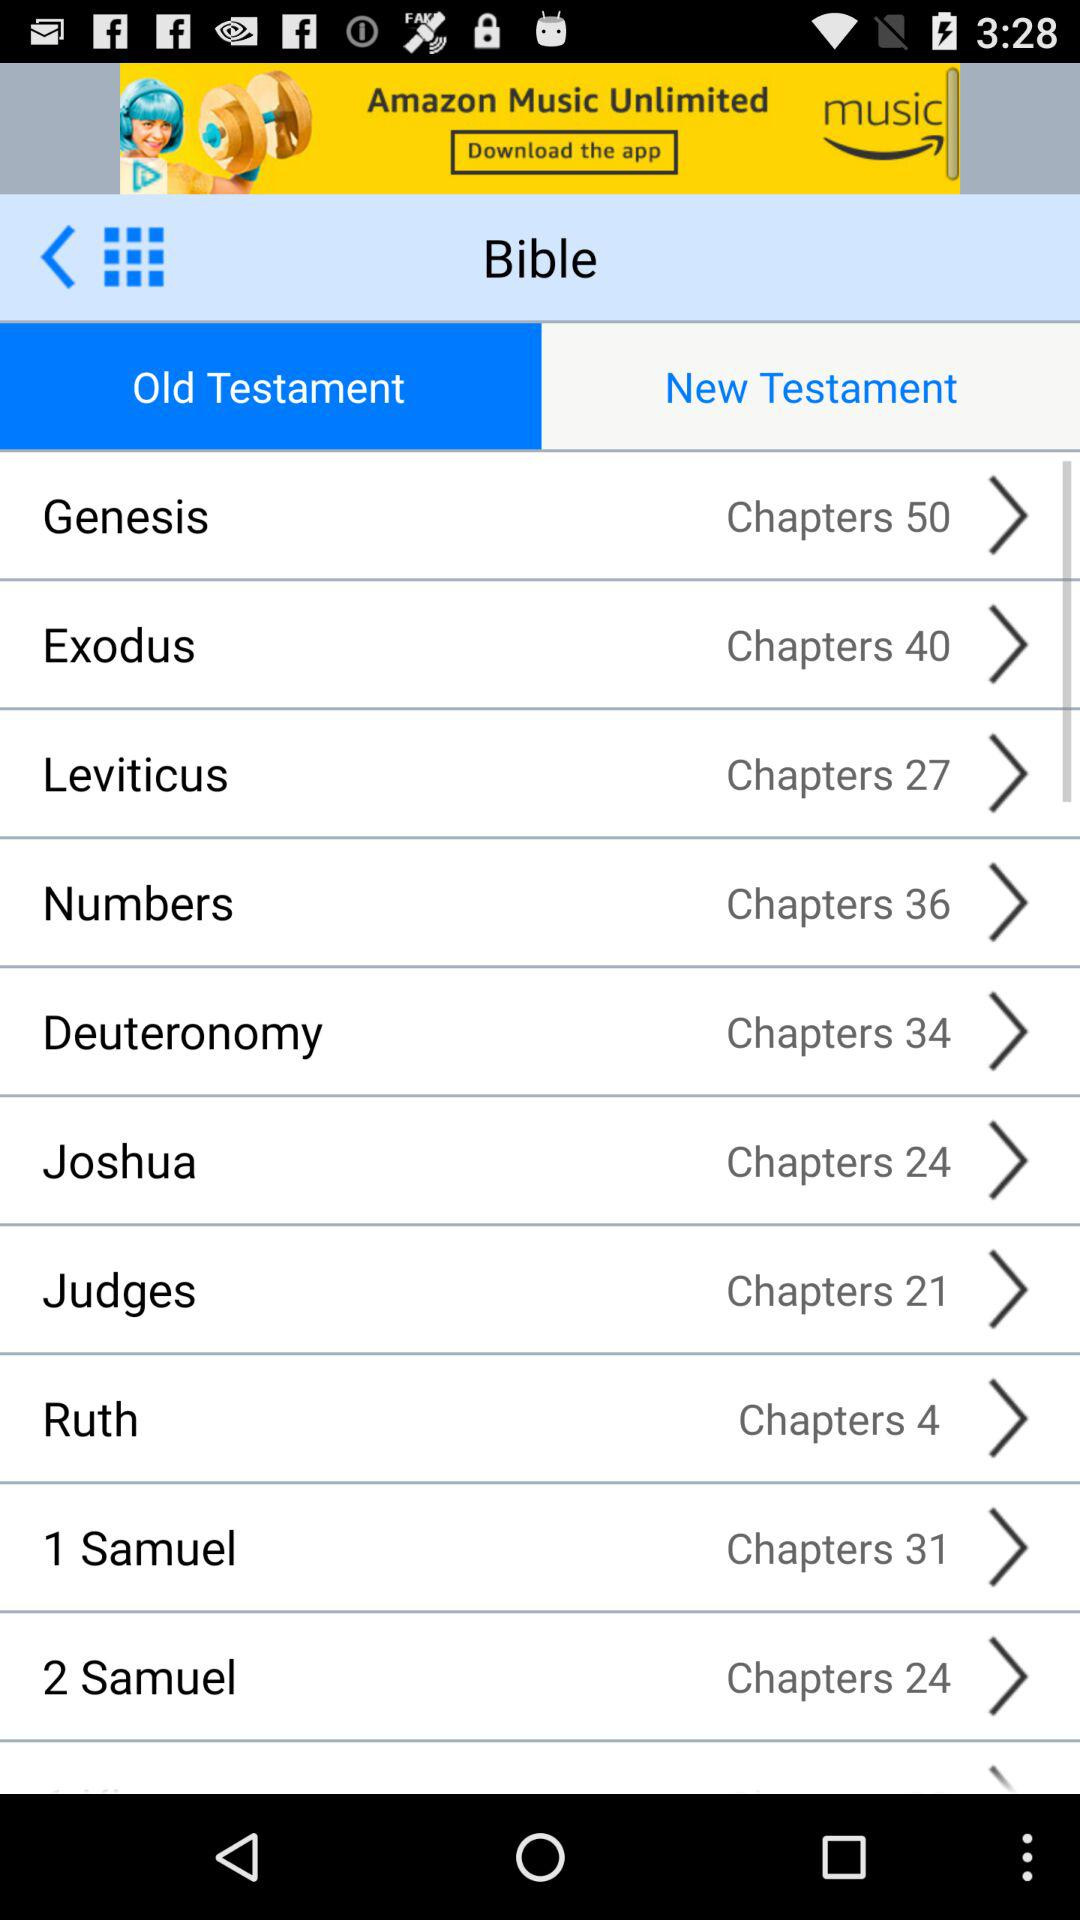How many chapters are available in "Judges"? There are 21 chapters. 